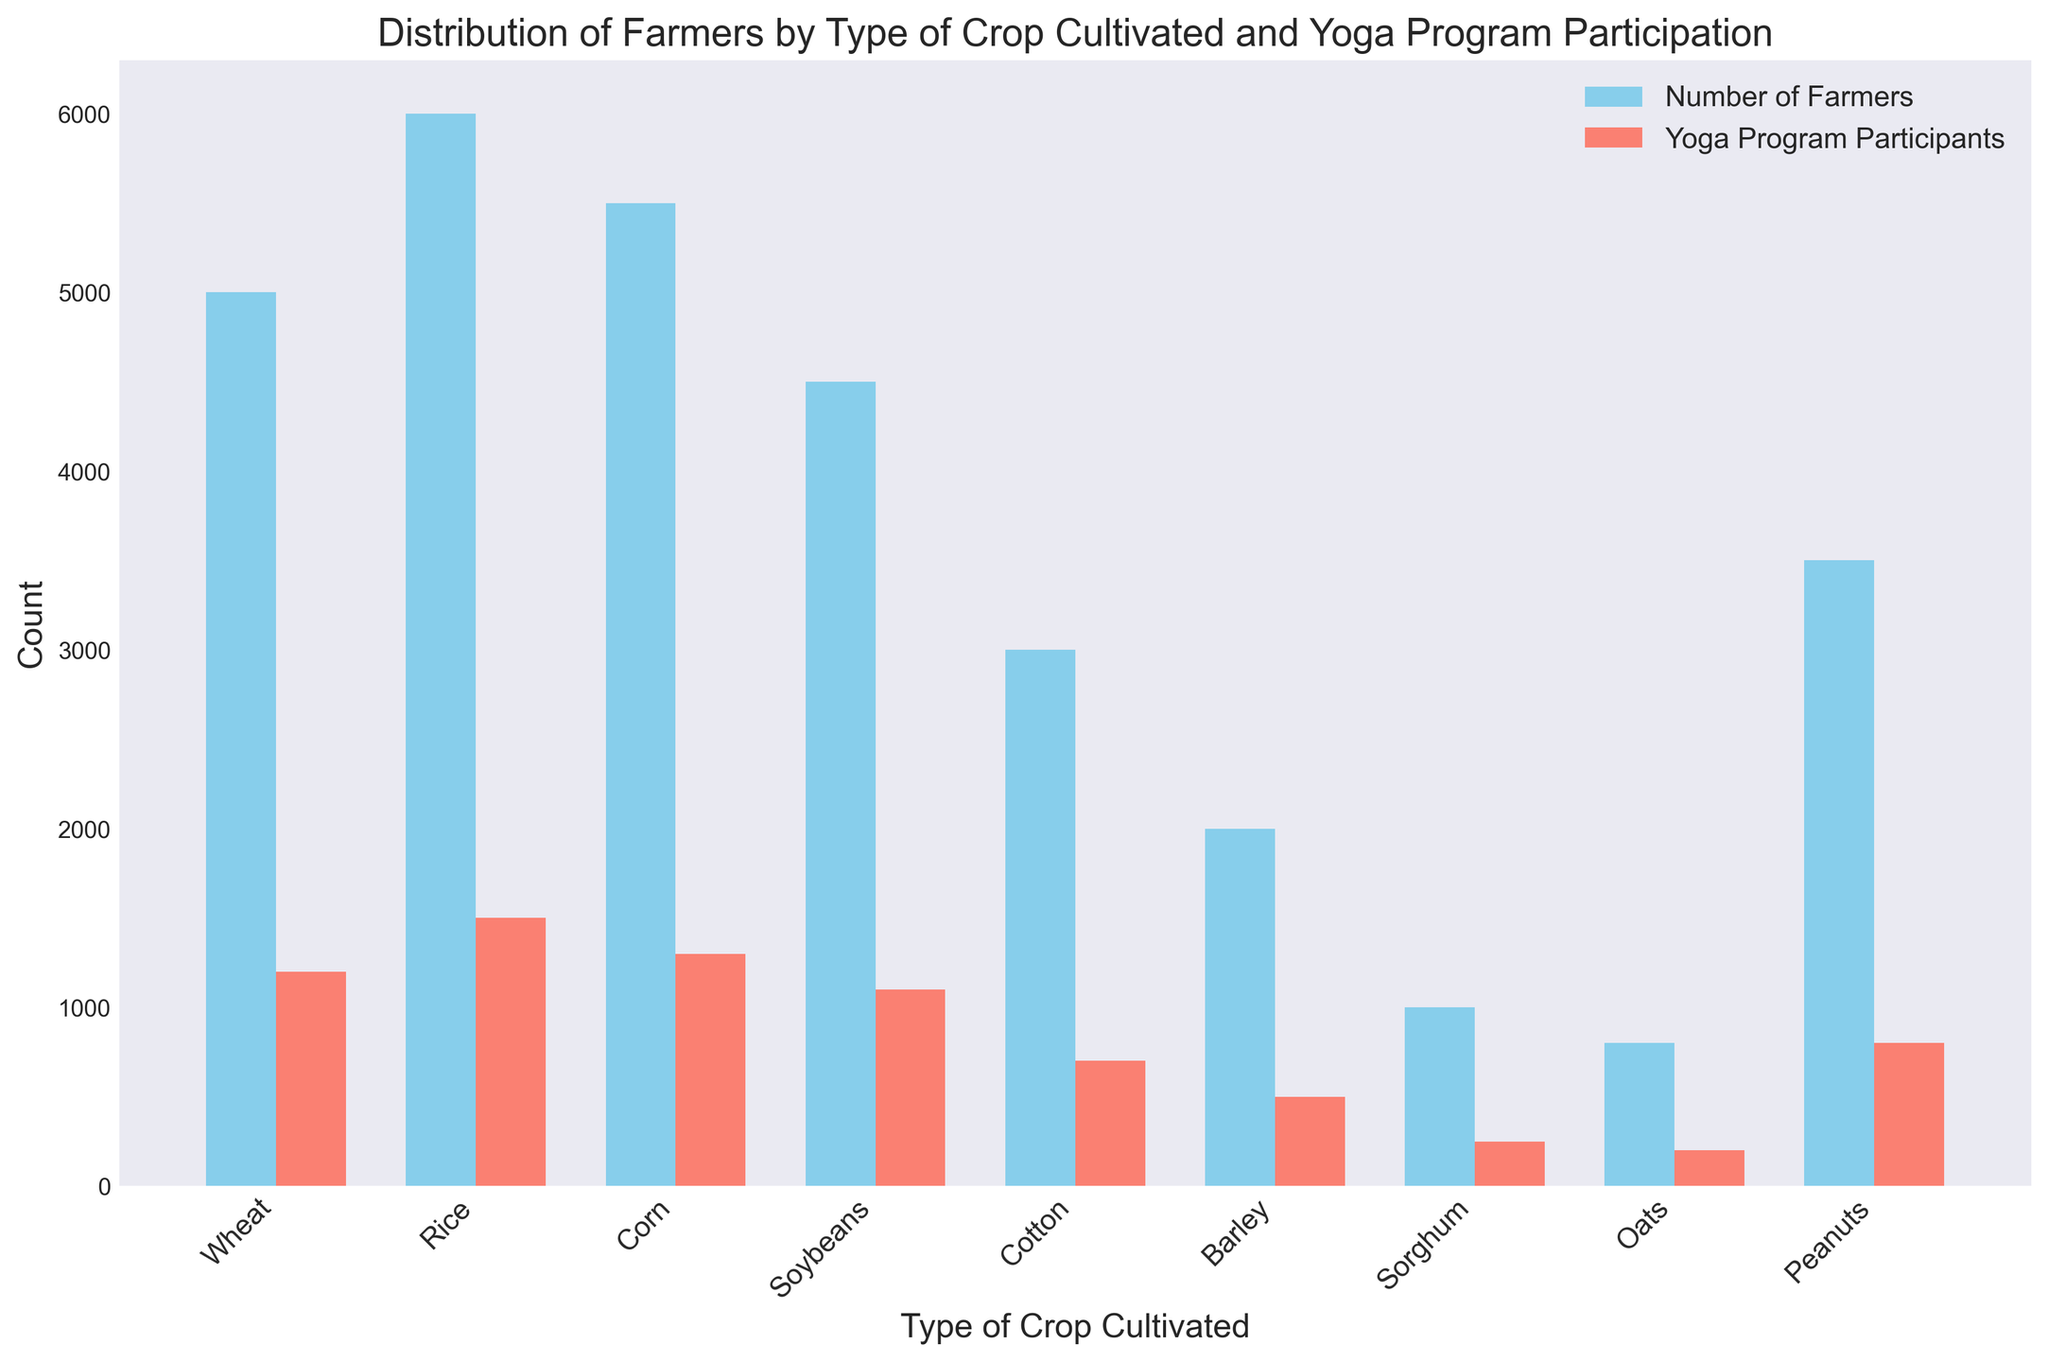Which type of crop cultivated has the highest number of yoga program participants? By observing the highest bar in the 'Yoga Program Participants' column, you can see Rice has the tallest bar, indicating it has the highest number of yoga participants.
Answer: Rice Which type of crop cultivated has the least number of farmers? By identifying the shortest bar in the 'Number of Farmers' column, you can see that Oats has the shortest bar, indicating it has the least number of farmers.
Answer: Oats What is the total number of farmers cultivating Wheat, Corn, and Soybeans? Add the number of farmers cultivating each crop: Wheat (5000) + Corn (5500) + Soybeans (4500). This sums up to 15000.
Answer: 15000 Compare the number of farmers cultivating Rice and Cotton. Which is greater and by how much? By comparing the heights of the bars for Rice and Cotton under 'Number of Farmers', you can see Rice (6000) is greater than Cotton (3000). The difference is 6000 - 3000 = 3000.
Answer: Rice, 3000 Which crop type has more participants in yoga programs, Peanuts or Barley? By comparing the heights of the bars for Peanuts and Barley under 'Yoga Program Participants', you can see the Peanuts bar is taller than the Barley bar.
Answer: Peanuts Are there more farmers cultivating Barley or participating in yoga programs from Soybeans farmers? Compare the 'Number of Farmers' for Barley (2000) with 'Yoga Program Participants' for Soybeans (1100). Since 2000 > 1100, more farmers cultivate Barley.
Answer: Barley Calculate the average number of yoga program participants for Wheat, Barley, and Oats. Sum the yoga participants for Wheat (1200), Barley (500), and Oats (200), which equals 1900. Divide by 3 to get the average: 1900 / 3 = 633.33.
Answer: 633.33 What's the difference between the number of farmers cultivating Soybeans and the number of yoga program participants in Corn? Subtract the number of yoga participants for Corn (1300) from the number of farmers for Soybeans (4500): 4500 - 1300 = 3200.
Answer: 3200 For which type of crop is the number of farmers almost double the number of yoga program participants? By comparing each crop's 'Number of Farmers' with its 'Yoga Program Participants', get that Cotton has 3000 farmers and 700 participants, and 3000 is roughly double 700.
Answer: Cotton 